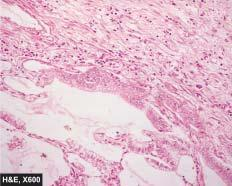re a, matted mass of lymph nodes lined by cuboidal to tall columnar and mucin-secreting tumour cells with papillary growth pattern?
Answer the question using a single word or phrase. No 